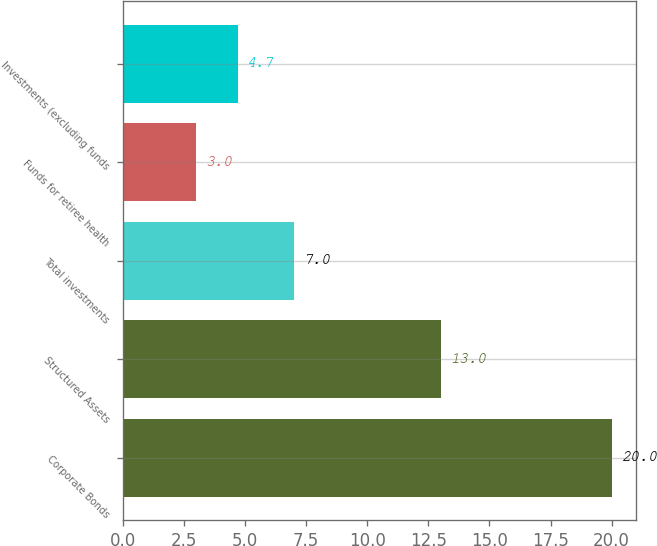Convert chart to OTSL. <chart><loc_0><loc_0><loc_500><loc_500><bar_chart><fcel>Corporate Bonds<fcel>Structured Assets<fcel>Total investments<fcel>Funds for retiree health<fcel>Investments (excluding funds<nl><fcel>20<fcel>13<fcel>7<fcel>3<fcel>4.7<nl></chart> 